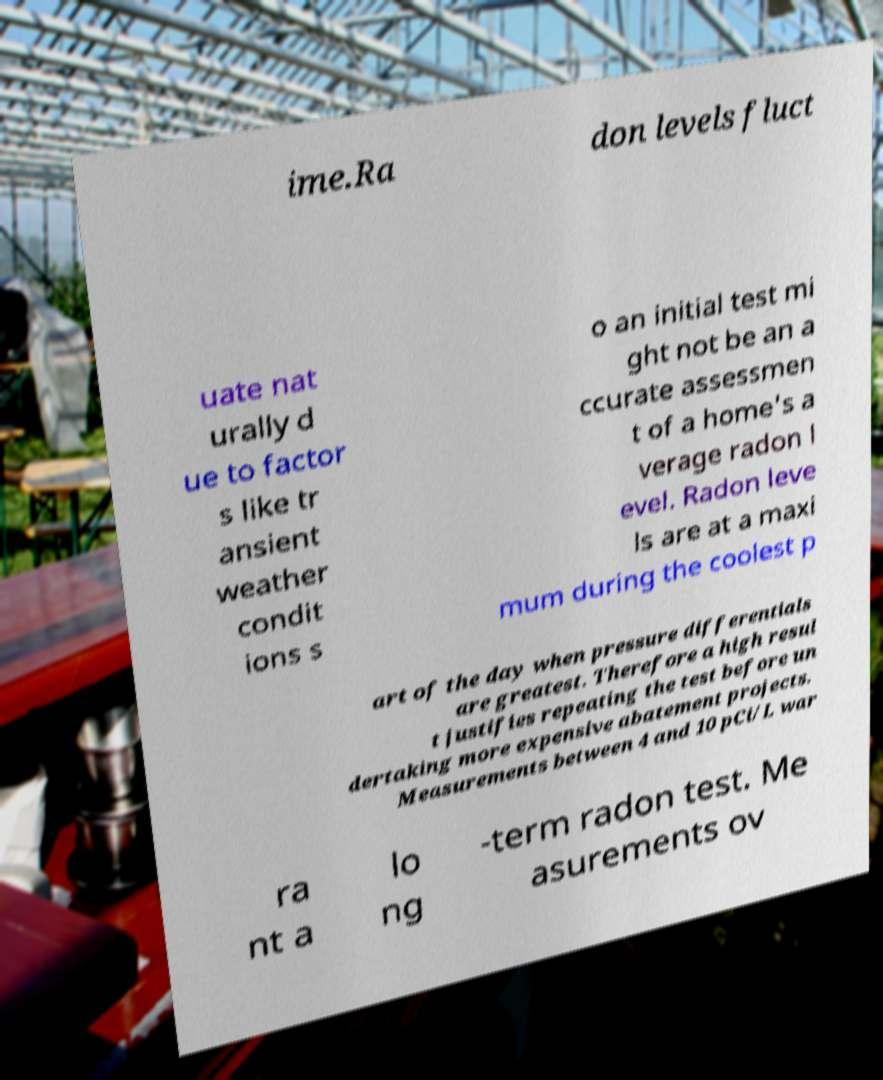What messages or text are displayed in this image? I need them in a readable, typed format. ime.Ra don levels fluct uate nat urally d ue to factor s like tr ansient weather condit ions s o an initial test mi ght not be an a ccurate assessmen t of a home's a verage radon l evel. Radon leve ls are at a maxi mum during the coolest p art of the day when pressure differentials are greatest. Therefore a high resul t justifies repeating the test before un dertaking more expensive abatement projects. Measurements between 4 and 10 pCi/L war ra nt a lo ng -term radon test. Me asurements ov 